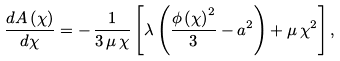Convert formula to latex. <formula><loc_0><loc_0><loc_500><loc_500>\frac { d A \left ( \chi \right ) } { d \chi } = - \, \frac { 1 } { 3 \, \mu \, \chi } \left [ \lambda \left ( \frac { \phi \left ( \chi \right ) ^ { 2 } } { 3 } - a ^ { 2 } \right ) + \mu \, \chi ^ { 2 } \right ] ,</formula> 